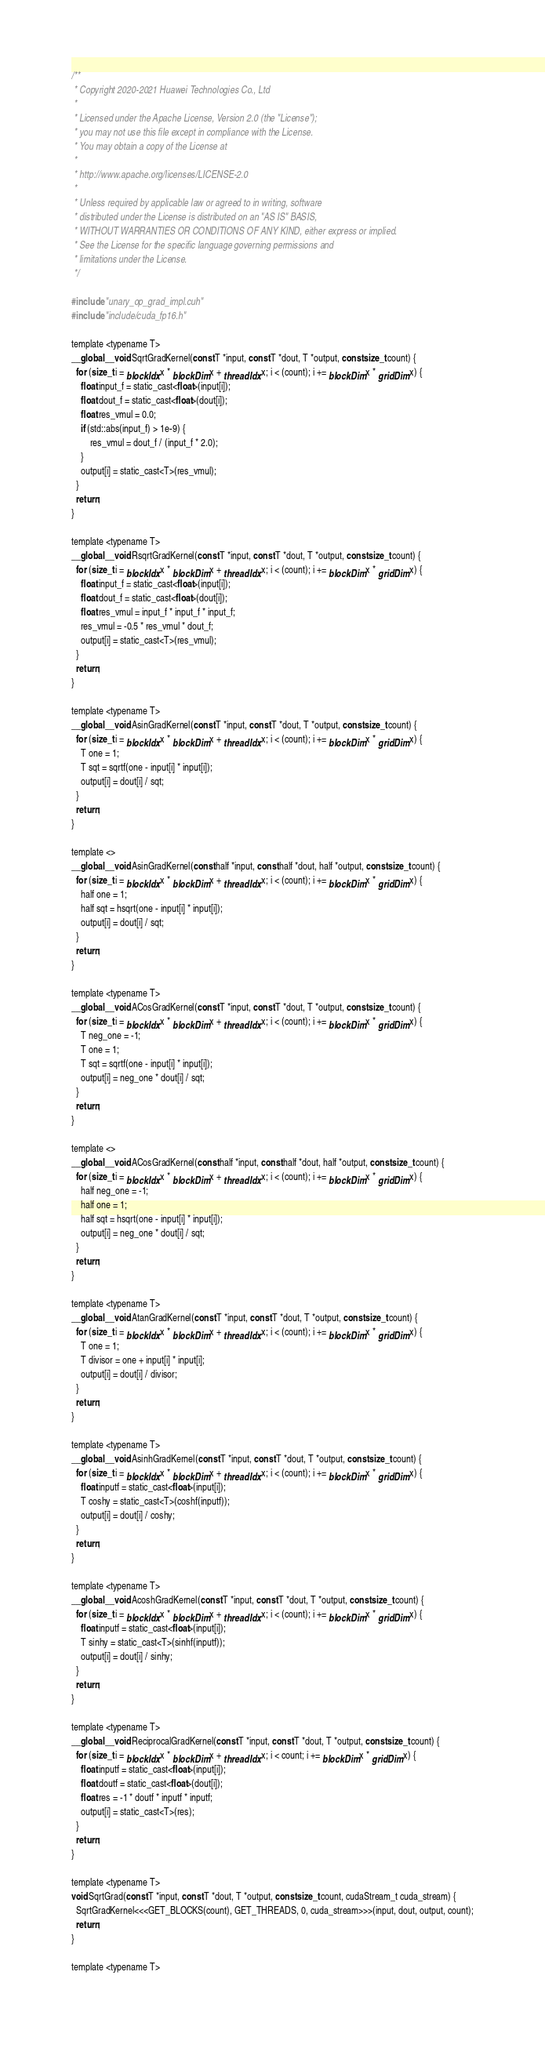Convert code to text. <code><loc_0><loc_0><loc_500><loc_500><_Cuda_>/**
 * Copyright 2020-2021 Huawei Technologies Co., Ltd
 *
 * Licensed under the Apache License, Version 2.0 (the "License");
 * you may not use this file except in compliance with the License.
 * You may obtain a copy of the License at
 *
 * http://www.apache.org/licenses/LICENSE-2.0
 *
 * Unless required by applicable law or agreed to in writing, software
 * distributed under the License is distributed on an "AS IS" BASIS,
 * WITHOUT WARRANTIES OR CONDITIONS OF ANY KIND, either express or implied.
 * See the License for the specific language governing permissions and
 * limitations under the License.
 */

#include "unary_op_grad_impl.cuh"
#include "include/cuda_fp16.h"

template <typename T>
__global__ void SqrtGradKernel(const T *input, const T *dout, T *output, const size_t count) {
  for (size_t i = blockIdx.x * blockDim.x + threadIdx.x; i < (count); i += blockDim.x * gridDim.x) {
    float input_f = static_cast<float>(input[i]);
    float dout_f = static_cast<float>(dout[i]);
    float res_vmul = 0.0;
    if (std::abs(input_f) > 1e-9) {
        res_vmul = dout_f / (input_f * 2.0);
    }
    output[i] = static_cast<T>(res_vmul);
  }
  return;
}

template <typename T>
__global__ void RsqrtGradKernel(const T *input, const T *dout, T *output, const size_t count) {
  for (size_t i = blockIdx.x * blockDim.x + threadIdx.x; i < (count); i += blockDim.x * gridDim.x) {
    float input_f = static_cast<float>(input[i]);
    float dout_f = static_cast<float>(dout[i]);
    float res_vmul = input_f * input_f * input_f;
    res_vmul = -0.5 * res_vmul * dout_f;
    output[i] = static_cast<T>(res_vmul);
  }
  return;
}

template <typename T>
__global__ void AsinGradKernel(const T *input, const T *dout, T *output, const size_t count) {
  for (size_t i = blockIdx.x * blockDim.x + threadIdx.x; i < (count); i += blockDim.x * gridDim.x) {
    T one = 1;
    T sqt = sqrtf(one - input[i] * input[i]);
    output[i] = dout[i] / sqt;
  }
  return;
}

template <>
__global__ void AsinGradKernel(const half *input, const half *dout, half *output, const size_t count) {
  for (size_t i = blockIdx.x * blockDim.x + threadIdx.x; i < (count); i += blockDim.x * gridDim.x) {
    half one = 1;
    half sqt = hsqrt(one - input[i] * input[i]);
    output[i] = dout[i] / sqt;
  }
  return;
}

template <typename T>
__global__ void ACosGradKernel(const T *input, const T *dout, T *output, const size_t count) {
  for (size_t i = blockIdx.x * blockDim.x + threadIdx.x; i < (count); i += blockDim.x * gridDim.x) {
    T neg_one = -1;
    T one = 1;
    T sqt = sqrtf(one - input[i] * input[i]);
    output[i] = neg_one * dout[i] / sqt;
  }
  return;
}

template <>
__global__ void ACosGradKernel(const half *input, const half *dout, half *output, const size_t count) {
  for (size_t i = blockIdx.x * blockDim.x + threadIdx.x; i < (count); i += blockDim.x * gridDim.x) {
    half neg_one = -1;
    half one = 1;
    half sqt = hsqrt(one - input[i] * input[i]);
    output[i] = neg_one * dout[i] / sqt;
  }
  return;
}

template <typename T>
__global__ void AtanGradKernel(const T *input, const T *dout, T *output, const size_t count) {
  for (size_t i = blockIdx.x * blockDim.x + threadIdx.x; i < (count); i += blockDim.x * gridDim.x) {
    T one = 1;
    T divisor = one + input[i] * input[i];
    output[i] = dout[i] / divisor;
  }
  return;
}

template <typename T>
__global__ void AsinhGradKernel(const T *input, const T *dout, T *output, const size_t count) {
  for (size_t i = blockIdx.x * blockDim.x + threadIdx.x; i < (count); i += blockDim.x * gridDim.x) {
    float inputf = static_cast<float>(input[i]);
    T coshy = static_cast<T>(coshf(inputf));
    output[i] = dout[i] / coshy;
  }
  return;
}

template <typename T>
__global__ void AcoshGradKernel(const T *input, const T *dout, T *output, const size_t count) {
  for (size_t i = blockIdx.x * blockDim.x + threadIdx.x; i < (count); i += blockDim.x * gridDim.x) {
    float inputf = static_cast<float>(input[i]);
    T sinhy = static_cast<T>(sinhf(inputf));
    output[i] = dout[i] / sinhy;
  }
  return;
}

template <typename T>
__global__ void ReciprocalGradKernel(const T *input, const T *dout, T *output, const size_t count) {
  for (size_t i = blockIdx.x * blockDim.x + threadIdx.x; i < count; i += blockDim.x * gridDim.x) {
    float inputf = static_cast<float>(input[i]);
    float doutf = static_cast<float>(dout[i]);
    float res = -1 * doutf * inputf * inputf;
    output[i] = static_cast<T>(res);
  }
  return;
}

template <typename T>
void SqrtGrad(const T *input, const T *dout, T *output, const size_t count, cudaStream_t cuda_stream) {
  SqrtGradKernel<<<GET_BLOCKS(count), GET_THREADS, 0, cuda_stream>>>(input, dout, output, count);
  return;
}

template <typename T></code> 